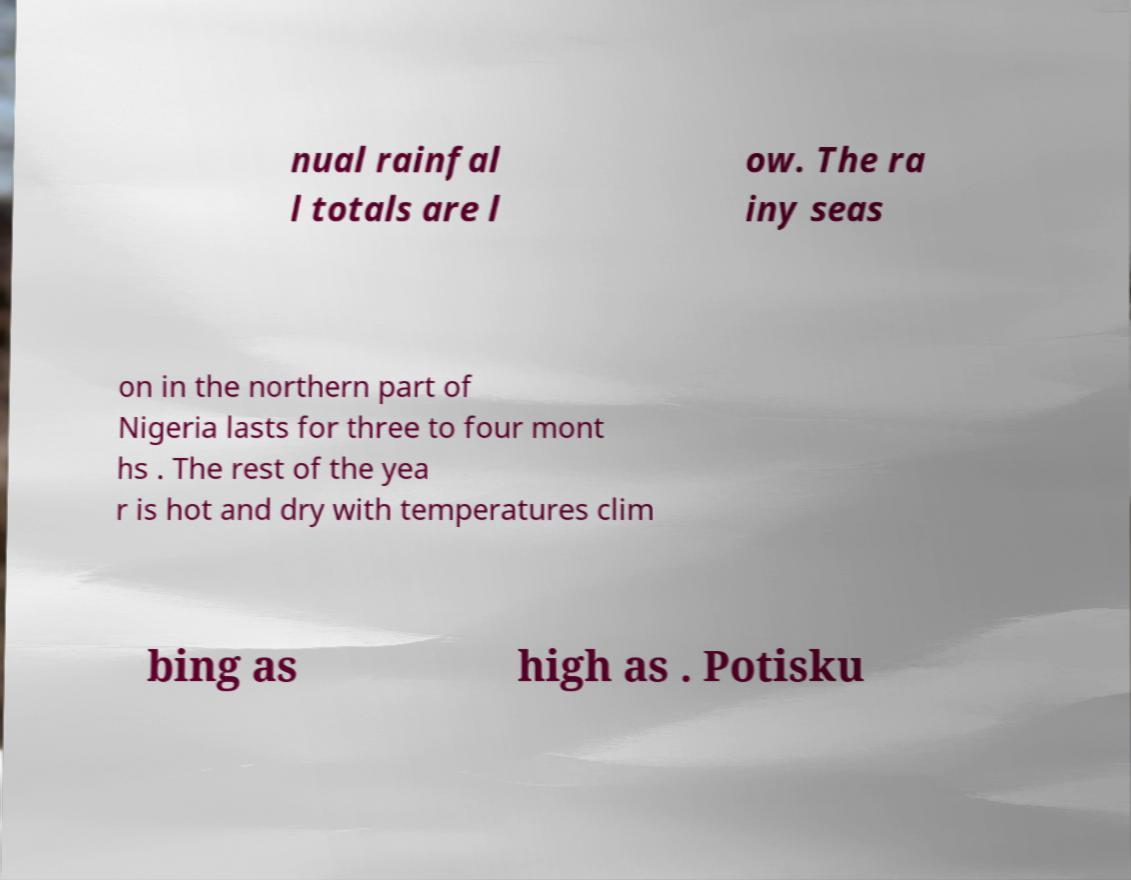Please read and relay the text visible in this image. What does it say? nual rainfal l totals are l ow. The ra iny seas on in the northern part of Nigeria lasts for three to four mont hs . The rest of the yea r is hot and dry with temperatures clim bing as high as . Potisku 